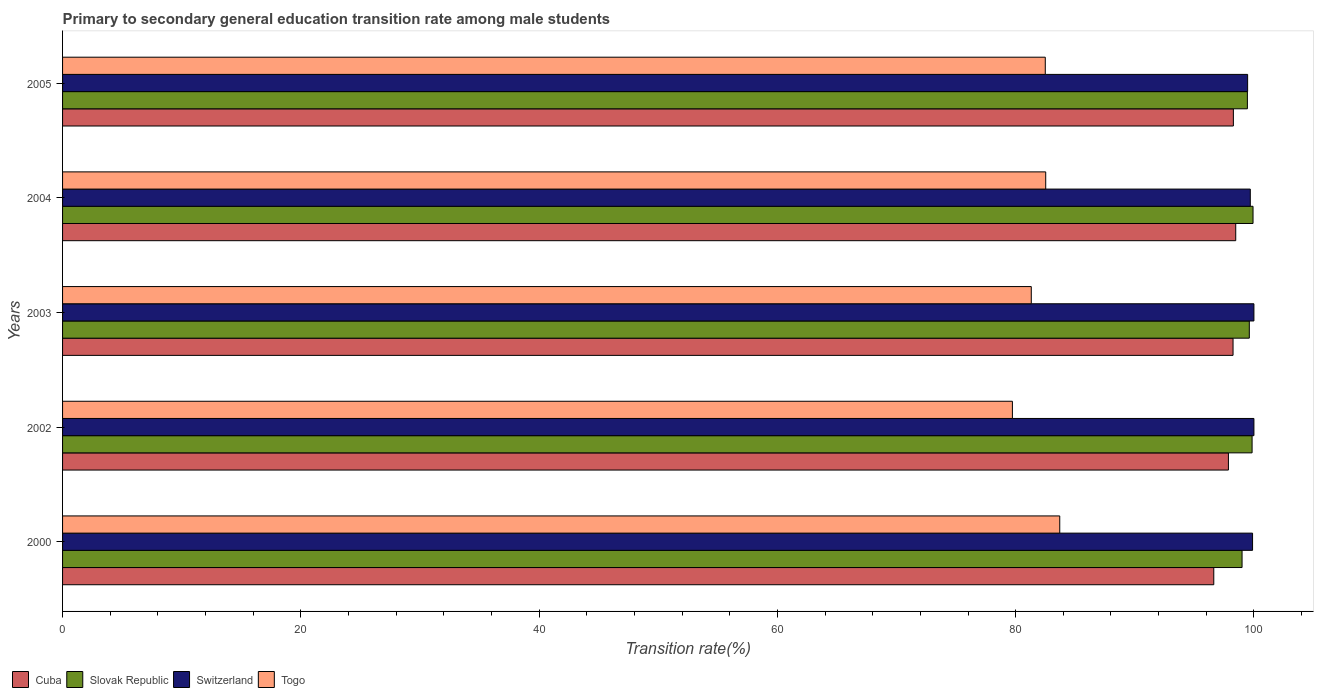How many groups of bars are there?
Keep it short and to the point. 5. Are the number of bars on each tick of the Y-axis equal?
Provide a succinct answer. Yes. How many bars are there on the 1st tick from the top?
Your response must be concise. 4. How many bars are there on the 3rd tick from the bottom?
Give a very brief answer. 4. In how many cases, is the number of bars for a given year not equal to the number of legend labels?
Keep it short and to the point. 0. What is the transition rate in Togo in 2000?
Offer a terse response. 83.7. Across all years, what is the minimum transition rate in Cuba?
Your response must be concise. 96.63. In which year was the transition rate in Slovak Republic maximum?
Offer a very short reply. 2004. What is the total transition rate in Slovak Republic in the graph?
Ensure brevity in your answer.  497.84. What is the difference between the transition rate in Togo in 2003 and that in 2005?
Give a very brief answer. -1.17. What is the difference between the transition rate in Cuba in 2004 and the transition rate in Togo in 2003?
Give a very brief answer. 17.16. What is the average transition rate in Cuba per year?
Provide a succinct answer. 97.9. In the year 2005, what is the difference between the transition rate in Cuba and transition rate in Togo?
Provide a short and direct response. 15.79. In how many years, is the transition rate in Slovak Republic greater than 12 %?
Offer a very short reply. 5. What is the ratio of the transition rate in Cuba in 2002 to that in 2003?
Provide a succinct answer. 1. Is the transition rate in Togo in 2000 less than that in 2005?
Your response must be concise. No. Is the difference between the transition rate in Cuba in 2003 and 2004 greater than the difference between the transition rate in Togo in 2003 and 2004?
Ensure brevity in your answer.  Yes. What is the difference between the highest and the second highest transition rate in Togo?
Make the answer very short. 1.18. What is the difference between the highest and the lowest transition rate in Togo?
Give a very brief answer. 3.97. Is it the case that in every year, the sum of the transition rate in Togo and transition rate in Switzerland is greater than the sum of transition rate in Cuba and transition rate in Slovak Republic?
Your response must be concise. Yes. What does the 3rd bar from the top in 2005 represents?
Provide a succinct answer. Slovak Republic. What does the 2nd bar from the bottom in 2004 represents?
Your answer should be compact. Slovak Republic. How many bars are there?
Give a very brief answer. 20. Are all the bars in the graph horizontal?
Provide a succinct answer. Yes. How many years are there in the graph?
Give a very brief answer. 5. Are the values on the major ticks of X-axis written in scientific E-notation?
Give a very brief answer. No. Does the graph contain any zero values?
Your answer should be very brief. No. Where does the legend appear in the graph?
Your response must be concise. Bottom left. How many legend labels are there?
Offer a terse response. 4. What is the title of the graph?
Offer a very short reply. Primary to secondary general education transition rate among male students. Does "Saudi Arabia" appear as one of the legend labels in the graph?
Your answer should be very brief. No. What is the label or title of the X-axis?
Your response must be concise. Transition rate(%). What is the Transition rate(%) of Cuba in 2000?
Offer a very short reply. 96.63. What is the Transition rate(%) of Slovak Republic in 2000?
Provide a succinct answer. 99. What is the Transition rate(%) of Switzerland in 2000?
Ensure brevity in your answer.  99.89. What is the Transition rate(%) of Togo in 2000?
Provide a short and direct response. 83.7. What is the Transition rate(%) in Cuba in 2002?
Offer a terse response. 97.86. What is the Transition rate(%) of Slovak Republic in 2002?
Offer a very short reply. 99.85. What is the Transition rate(%) in Switzerland in 2002?
Offer a terse response. 100. What is the Transition rate(%) of Togo in 2002?
Provide a succinct answer. 79.73. What is the Transition rate(%) of Cuba in 2003?
Ensure brevity in your answer.  98.25. What is the Transition rate(%) of Slovak Republic in 2003?
Your response must be concise. 99.61. What is the Transition rate(%) of Switzerland in 2003?
Make the answer very short. 100. What is the Transition rate(%) in Togo in 2003?
Ensure brevity in your answer.  81.31. What is the Transition rate(%) in Cuba in 2004?
Your answer should be very brief. 98.47. What is the Transition rate(%) of Slovak Republic in 2004?
Your response must be concise. 99.93. What is the Transition rate(%) in Switzerland in 2004?
Give a very brief answer. 99.7. What is the Transition rate(%) in Togo in 2004?
Ensure brevity in your answer.  82.52. What is the Transition rate(%) in Cuba in 2005?
Ensure brevity in your answer.  98.28. What is the Transition rate(%) of Slovak Republic in 2005?
Your answer should be compact. 99.45. What is the Transition rate(%) of Switzerland in 2005?
Provide a succinct answer. 99.47. What is the Transition rate(%) in Togo in 2005?
Your response must be concise. 82.49. Across all years, what is the maximum Transition rate(%) of Cuba?
Ensure brevity in your answer.  98.47. Across all years, what is the maximum Transition rate(%) of Slovak Republic?
Keep it short and to the point. 99.93. Across all years, what is the maximum Transition rate(%) in Togo?
Provide a short and direct response. 83.7. Across all years, what is the minimum Transition rate(%) in Cuba?
Ensure brevity in your answer.  96.63. Across all years, what is the minimum Transition rate(%) in Slovak Republic?
Keep it short and to the point. 99. Across all years, what is the minimum Transition rate(%) in Switzerland?
Your response must be concise. 99.47. Across all years, what is the minimum Transition rate(%) of Togo?
Your answer should be compact. 79.73. What is the total Transition rate(%) of Cuba in the graph?
Offer a terse response. 489.49. What is the total Transition rate(%) in Slovak Republic in the graph?
Keep it short and to the point. 497.84. What is the total Transition rate(%) in Switzerland in the graph?
Keep it short and to the point. 499.05. What is the total Transition rate(%) of Togo in the graph?
Give a very brief answer. 409.75. What is the difference between the Transition rate(%) of Cuba in 2000 and that in 2002?
Give a very brief answer. -1.23. What is the difference between the Transition rate(%) in Slovak Republic in 2000 and that in 2002?
Provide a succinct answer. -0.84. What is the difference between the Transition rate(%) in Switzerland in 2000 and that in 2002?
Your response must be concise. -0.11. What is the difference between the Transition rate(%) of Togo in 2000 and that in 2002?
Provide a succinct answer. 3.97. What is the difference between the Transition rate(%) of Cuba in 2000 and that in 2003?
Give a very brief answer. -1.62. What is the difference between the Transition rate(%) in Slovak Republic in 2000 and that in 2003?
Offer a very short reply. -0.61. What is the difference between the Transition rate(%) of Switzerland in 2000 and that in 2003?
Offer a very short reply. -0.11. What is the difference between the Transition rate(%) in Togo in 2000 and that in 2003?
Provide a succinct answer. 2.39. What is the difference between the Transition rate(%) of Cuba in 2000 and that in 2004?
Keep it short and to the point. -1.84. What is the difference between the Transition rate(%) of Slovak Republic in 2000 and that in 2004?
Provide a short and direct response. -0.92. What is the difference between the Transition rate(%) in Switzerland in 2000 and that in 2004?
Offer a terse response. 0.19. What is the difference between the Transition rate(%) of Togo in 2000 and that in 2004?
Provide a short and direct response. 1.18. What is the difference between the Transition rate(%) of Cuba in 2000 and that in 2005?
Your answer should be very brief. -1.64. What is the difference between the Transition rate(%) of Slovak Republic in 2000 and that in 2005?
Ensure brevity in your answer.  -0.45. What is the difference between the Transition rate(%) in Switzerland in 2000 and that in 2005?
Offer a very short reply. 0.41. What is the difference between the Transition rate(%) of Togo in 2000 and that in 2005?
Your response must be concise. 1.21. What is the difference between the Transition rate(%) of Cuba in 2002 and that in 2003?
Provide a succinct answer. -0.39. What is the difference between the Transition rate(%) in Slovak Republic in 2002 and that in 2003?
Make the answer very short. 0.23. What is the difference between the Transition rate(%) of Togo in 2002 and that in 2003?
Your answer should be compact. -1.58. What is the difference between the Transition rate(%) of Cuba in 2002 and that in 2004?
Keep it short and to the point. -0.61. What is the difference between the Transition rate(%) in Slovak Republic in 2002 and that in 2004?
Your answer should be very brief. -0.08. What is the difference between the Transition rate(%) of Switzerland in 2002 and that in 2004?
Make the answer very short. 0.3. What is the difference between the Transition rate(%) of Togo in 2002 and that in 2004?
Your answer should be very brief. -2.8. What is the difference between the Transition rate(%) in Cuba in 2002 and that in 2005?
Your answer should be compact. -0.42. What is the difference between the Transition rate(%) of Slovak Republic in 2002 and that in 2005?
Provide a succinct answer. 0.39. What is the difference between the Transition rate(%) in Switzerland in 2002 and that in 2005?
Make the answer very short. 0.53. What is the difference between the Transition rate(%) in Togo in 2002 and that in 2005?
Give a very brief answer. -2.76. What is the difference between the Transition rate(%) in Cuba in 2003 and that in 2004?
Your answer should be very brief. -0.23. What is the difference between the Transition rate(%) in Slovak Republic in 2003 and that in 2004?
Ensure brevity in your answer.  -0.31. What is the difference between the Transition rate(%) in Switzerland in 2003 and that in 2004?
Offer a terse response. 0.3. What is the difference between the Transition rate(%) of Togo in 2003 and that in 2004?
Give a very brief answer. -1.21. What is the difference between the Transition rate(%) in Cuba in 2003 and that in 2005?
Ensure brevity in your answer.  -0.03. What is the difference between the Transition rate(%) of Slovak Republic in 2003 and that in 2005?
Your answer should be compact. 0.16. What is the difference between the Transition rate(%) of Switzerland in 2003 and that in 2005?
Provide a succinct answer. 0.53. What is the difference between the Transition rate(%) in Togo in 2003 and that in 2005?
Provide a succinct answer. -1.17. What is the difference between the Transition rate(%) in Cuba in 2004 and that in 2005?
Offer a very short reply. 0.2. What is the difference between the Transition rate(%) in Slovak Republic in 2004 and that in 2005?
Provide a succinct answer. 0.47. What is the difference between the Transition rate(%) of Switzerland in 2004 and that in 2005?
Keep it short and to the point. 0.22. What is the difference between the Transition rate(%) in Togo in 2004 and that in 2005?
Provide a short and direct response. 0.04. What is the difference between the Transition rate(%) in Cuba in 2000 and the Transition rate(%) in Slovak Republic in 2002?
Make the answer very short. -3.21. What is the difference between the Transition rate(%) in Cuba in 2000 and the Transition rate(%) in Switzerland in 2002?
Offer a very short reply. -3.37. What is the difference between the Transition rate(%) of Cuba in 2000 and the Transition rate(%) of Togo in 2002?
Offer a terse response. 16.9. What is the difference between the Transition rate(%) in Slovak Republic in 2000 and the Transition rate(%) in Switzerland in 2002?
Offer a very short reply. -1. What is the difference between the Transition rate(%) in Slovak Republic in 2000 and the Transition rate(%) in Togo in 2002?
Your response must be concise. 19.28. What is the difference between the Transition rate(%) in Switzerland in 2000 and the Transition rate(%) in Togo in 2002?
Keep it short and to the point. 20.16. What is the difference between the Transition rate(%) in Cuba in 2000 and the Transition rate(%) in Slovak Republic in 2003?
Give a very brief answer. -2.98. What is the difference between the Transition rate(%) in Cuba in 2000 and the Transition rate(%) in Switzerland in 2003?
Offer a terse response. -3.37. What is the difference between the Transition rate(%) of Cuba in 2000 and the Transition rate(%) of Togo in 2003?
Your response must be concise. 15.32. What is the difference between the Transition rate(%) in Slovak Republic in 2000 and the Transition rate(%) in Switzerland in 2003?
Ensure brevity in your answer.  -1. What is the difference between the Transition rate(%) in Slovak Republic in 2000 and the Transition rate(%) in Togo in 2003?
Ensure brevity in your answer.  17.69. What is the difference between the Transition rate(%) in Switzerland in 2000 and the Transition rate(%) in Togo in 2003?
Provide a succinct answer. 18.57. What is the difference between the Transition rate(%) in Cuba in 2000 and the Transition rate(%) in Slovak Republic in 2004?
Your response must be concise. -3.29. What is the difference between the Transition rate(%) of Cuba in 2000 and the Transition rate(%) of Switzerland in 2004?
Your answer should be very brief. -3.06. What is the difference between the Transition rate(%) in Cuba in 2000 and the Transition rate(%) in Togo in 2004?
Ensure brevity in your answer.  14.11. What is the difference between the Transition rate(%) in Slovak Republic in 2000 and the Transition rate(%) in Switzerland in 2004?
Keep it short and to the point. -0.69. What is the difference between the Transition rate(%) of Slovak Republic in 2000 and the Transition rate(%) of Togo in 2004?
Give a very brief answer. 16.48. What is the difference between the Transition rate(%) of Switzerland in 2000 and the Transition rate(%) of Togo in 2004?
Offer a terse response. 17.36. What is the difference between the Transition rate(%) in Cuba in 2000 and the Transition rate(%) in Slovak Republic in 2005?
Your answer should be compact. -2.82. What is the difference between the Transition rate(%) in Cuba in 2000 and the Transition rate(%) in Switzerland in 2005?
Provide a short and direct response. -2.84. What is the difference between the Transition rate(%) in Cuba in 2000 and the Transition rate(%) in Togo in 2005?
Provide a short and direct response. 14.14. What is the difference between the Transition rate(%) in Slovak Republic in 2000 and the Transition rate(%) in Switzerland in 2005?
Ensure brevity in your answer.  -0.47. What is the difference between the Transition rate(%) in Slovak Republic in 2000 and the Transition rate(%) in Togo in 2005?
Give a very brief answer. 16.52. What is the difference between the Transition rate(%) of Switzerland in 2000 and the Transition rate(%) of Togo in 2005?
Offer a terse response. 17.4. What is the difference between the Transition rate(%) of Cuba in 2002 and the Transition rate(%) of Slovak Republic in 2003?
Provide a short and direct response. -1.75. What is the difference between the Transition rate(%) in Cuba in 2002 and the Transition rate(%) in Switzerland in 2003?
Provide a succinct answer. -2.14. What is the difference between the Transition rate(%) in Cuba in 2002 and the Transition rate(%) in Togo in 2003?
Give a very brief answer. 16.55. What is the difference between the Transition rate(%) of Slovak Republic in 2002 and the Transition rate(%) of Switzerland in 2003?
Provide a short and direct response. -0.15. What is the difference between the Transition rate(%) in Slovak Republic in 2002 and the Transition rate(%) in Togo in 2003?
Offer a terse response. 18.53. What is the difference between the Transition rate(%) in Switzerland in 2002 and the Transition rate(%) in Togo in 2003?
Make the answer very short. 18.69. What is the difference between the Transition rate(%) of Cuba in 2002 and the Transition rate(%) of Slovak Republic in 2004?
Provide a short and direct response. -2.07. What is the difference between the Transition rate(%) in Cuba in 2002 and the Transition rate(%) in Switzerland in 2004?
Your response must be concise. -1.84. What is the difference between the Transition rate(%) of Cuba in 2002 and the Transition rate(%) of Togo in 2004?
Make the answer very short. 15.34. What is the difference between the Transition rate(%) in Slovak Republic in 2002 and the Transition rate(%) in Switzerland in 2004?
Give a very brief answer. 0.15. What is the difference between the Transition rate(%) in Slovak Republic in 2002 and the Transition rate(%) in Togo in 2004?
Give a very brief answer. 17.32. What is the difference between the Transition rate(%) in Switzerland in 2002 and the Transition rate(%) in Togo in 2004?
Give a very brief answer. 17.48. What is the difference between the Transition rate(%) in Cuba in 2002 and the Transition rate(%) in Slovak Republic in 2005?
Keep it short and to the point. -1.59. What is the difference between the Transition rate(%) in Cuba in 2002 and the Transition rate(%) in Switzerland in 2005?
Your response must be concise. -1.61. What is the difference between the Transition rate(%) in Cuba in 2002 and the Transition rate(%) in Togo in 2005?
Provide a succinct answer. 15.37. What is the difference between the Transition rate(%) in Slovak Republic in 2002 and the Transition rate(%) in Switzerland in 2005?
Give a very brief answer. 0.37. What is the difference between the Transition rate(%) of Slovak Republic in 2002 and the Transition rate(%) of Togo in 2005?
Provide a succinct answer. 17.36. What is the difference between the Transition rate(%) in Switzerland in 2002 and the Transition rate(%) in Togo in 2005?
Provide a succinct answer. 17.51. What is the difference between the Transition rate(%) in Cuba in 2003 and the Transition rate(%) in Slovak Republic in 2004?
Provide a short and direct response. -1.68. What is the difference between the Transition rate(%) in Cuba in 2003 and the Transition rate(%) in Switzerland in 2004?
Provide a succinct answer. -1.45. What is the difference between the Transition rate(%) of Cuba in 2003 and the Transition rate(%) of Togo in 2004?
Offer a terse response. 15.72. What is the difference between the Transition rate(%) in Slovak Republic in 2003 and the Transition rate(%) in Switzerland in 2004?
Ensure brevity in your answer.  -0.08. What is the difference between the Transition rate(%) in Slovak Republic in 2003 and the Transition rate(%) in Togo in 2004?
Offer a terse response. 17.09. What is the difference between the Transition rate(%) of Switzerland in 2003 and the Transition rate(%) of Togo in 2004?
Offer a terse response. 17.48. What is the difference between the Transition rate(%) in Cuba in 2003 and the Transition rate(%) in Slovak Republic in 2005?
Provide a short and direct response. -1.2. What is the difference between the Transition rate(%) in Cuba in 2003 and the Transition rate(%) in Switzerland in 2005?
Offer a very short reply. -1.22. What is the difference between the Transition rate(%) of Cuba in 2003 and the Transition rate(%) of Togo in 2005?
Your response must be concise. 15.76. What is the difference between the Transition rate(%) of Slovak Republic in 2003 and the Transition rate(%) of Switzerland in 2005?
Provide a succinct answer. 0.14. What is the difference between the Transition rate(%) in Slovak Republic in 2003 and the Transition rate(%) in Togo in 2005?
Keep it short and to the point. 17.13. What is the difference between the Transition rate(%) in Switzerland in 2003 and the Transition rate(%) in Togo in 2005?
Offer a very short reply. 17.51. What is the difference between the Transition rate(%) of Cuba in 2004 and the Transition rate(%) of Slovak Republic in 2005?
Make the answer very short. -0.98. What is the difference between the Transition rate(%) of Cuba in 2004 and the Transition rate(%) of Switzerland in 2005?
Your response must be concise. -1. What is the difference between the Transition rate(%) in Cuba in 2004 and the Transition rate(%) in Togo in 2005?
Your response must be concise. 15.99. What is the difference between the Transition rate(%) in Slovak Republic in 2004 and the Transition rate(%) in Switzerland in 2005?
Ensure brevity in your answer.  0.45. What is the difference between the Transition rate(%) of Slovak Republic in 2004 and the Transition rate(%) of Togo in 2005?
Offer a very short reply. 17.44. What is the difference between the Transition rate(%) in Switzerland in 2004 and the Transition rate(%) in Togo in 2005?
Keep it short and to the point. 17.21. What is the average Transition rate(%) in Cuba per year?
Provide a succinct answer. 97.9. What is the average Transition rate(%) in Slovak Republic per year?
Give a very brief answer. 99.57. What is the average Transition rate(%) in Switzerland per year?
Your response must be concise. 99.81. What is the average Transition rate(%) in Togo per year?
Keep it short and to the point. 81.95. In the year 2000, what is the difference between the Transition rate(%) of Cuba and Transition rate(%) of Slovak Republic?
Your answer should be compact. -2.37. In the year 2000, what is the difference between the Transition rate(%) in Cuba and Transition rate(%) in Switzerland?
Your answer should be compact. -3.26. In the year 2000, what is the difference between the Transition rate(%) in Cuba and Transition rate(%) in Togo?
Offer a very short reply. 12.93. In the year 2000, what is the difference between the Transition rate(%) in Slovak Republic and Transition rate(%) in Switzerland?
Your answer should be compact. -0.88. In the year 2000, what is the difference between the Transition rate(%) of Slovak Republic and Transition rate(%) of Togo?
Give a very brief answer. 15.3. In the year 2000, what is the difference between the Transition rate(%) of Switzerland and Transition rate(%) of Togo?
Provide a short and direct response. 16.19. In the year 2002, what is the difference between the Transition rate(%) of Cuba and Transition rate(%) of Slovak Republic?
Your answer should be very brief. -1.99. In the year 2002, what is the difference between the Transition rate(%) in Cuba and Transition rate(%) in Switzerland?
Ensure brevity in your answer.  -2.14. In the year 2002, what is the difference between the Transition rate(%) in Cuba and Transition rate(%) in Togo?
Your answer should be compact. 18.13. In the year 2002, what is the difference between the Transition rate(%) of Slovak Republic and Transition rate(%) of Switzerland?
Give a very brief answer. -0.15. In the year 2002, what is the difference between the Transition rate(%) in Slovak Republic and Transition rate(%) in Togo?
Your response must be concise. 20.12. In the year 2002, what is the difference between the Transition rate(%) of Switzerland and Transition rate(%) of Togo?
Make the answer very short. 20.27. In the year 2003, what is the difference between the Transition rate(%) of Cuba and Transition rate(%) of Slovak Republic?
Provide a short and direct response. -1.37. In the year 2003, what is the difference between the Transition rate(%) in Cuba and Transition rate(%) in Switzerland?
Your response must be concise. -1.75. In the year 2003, what is the difference between the Transition rate(%) in Cuba and Transition rate(%) in Togo?
Your response must be concise. 16.93. In the year 2003, what is the difference between the Transition rate(%) of Slovak Republic and Transition rate(%) of Switzerland?
Ensure brevity in your answer.  -0.39. In the year 2003, what is the difference between the Transition rate(%) of Slovak Republic and Transition rate(%) of Togo?
Give a very brief answer. 18.3. In the year 2003, what is the difference between the Transition rate(%) of Switzerland and Transition rate(%) of Togo?
Your answer should be compact. 18.69. In the year 2004, what is the difference between the Transition rate(%) of Cuba and Transition rate(%) of Slovak Republic?
Offer a terse response. -1.45. In the year 2004, what is the difference between the Transition rate(%) in Cuba and Transition rate(%) in Switzerland?
Offer a terse response. -1.22. In the year 2004, what is the difference between the Transition rate(%) in Cuba and Transition rate(%) in Togo?
Keep it short and to the point. 15.95. In the year 2004, what is the difference between the Transition rate(%) in Slovak Republic and Transition rate(%) in Switzerland?
Make the answer very short. 0.23. In the year 2004, what is the difference between the Transition rate(%) in Slovak Republic and Transition rate(%) in Togo?
Your answer should be compact. 17.4. In the year 2004, what is the difference between the Transition rate(%) of Switzerland and Transition rate(%) of Togo?
Your response must be concise. 17.17. In the year 2005, what is the difference between the Transition rate(%) in Cuba and Transition rate(%) in Slovak Republic?
Give a very brief answer. -1.18. In the year 2005, what is the difference between the Transition rate(%) in Cuba and Transition rate(%) in Switzerland?
Offer a terse response. -1.2. In the year 2005, what is the difference between the Transition rate(%) of Cuba and Transition rate(%) of Togo?
Your answer should be compact. 15.79. In the year 2005, what is the difference between the Transition rate(%) of Slovak Republic and Transition rate(%) of Switzerland?
Offer a terse response. -0.02. In the year 2005, what is the difference between the Transition rate(%) of Slovak Republic and Transition rate(%) of Togo?
Your answer should be compact. 16.96. In the year 2005, what is the difference between the Transition rate(%) of Switzerland and Transition rate(%) of Togo?
Make the answer very short. 16.98. What is the ratio of the Transition rate(%) in Cuba in 2000 to that in 2002?
Provide a short and direct response. 0.99. What is the ratio of the Transition rate(%) in Switzerland in 2000 to that in 2002?
Offer a terse response. 1. What is the ratio of the Transition rate(%) of Togo in 2000 to that in 2002?
Ensure brevity in your answer.  1.05. What is the ratio of the Transition rate(%) in Cuba in 2000 to that in 2003?
Give a very brief answer. 0.98. What is the ratio of the Transition rate(%) in Slovak Republic in 2000 to that in 2003?
Give a very brief answer. 0.99. What is the ratio of the Transition rate(%) of Switzerland in 2000 to that in 2003?
Provide a succinct answer. 1. What is the ratio of the Transition rate(%) in Togo in 2000 to that in 2003?
Provide a short and direct response. 1.03. What is the ratio of the Transition rate(%) in Cuba in 2000 to that in 2004?
Provide a succinct answer. 0.98. What is the ratio of the Transition rate(%) of Switzerland in 2000 to that in 2004?
Your answer should be compact. 1. What is the ratio of the Transition rate(%) of Togo in 2000 to that in 2004?
Offer a very short reply. 1.01. What is the ratio of the Transition rate(%) of Cuba in 2000 to that in 2005?
Make the answer very short. 0.98. What is the ratio of the Transition rate(%) in Togo in 2000 to that in 2005?
Offer a terse response. 1.01. What is the ratio of the Transition rate(%) of Togo in 2002 to that in 2003?
Your response must be concise. 0.98. What is the ratio of the Transition rate(%) of Cuba in 2002 to that in 2004?
Ensure brevity in your answer.  0.99. What is the ratio of the Transition rate(%) of Togo in 2002 to that in 2004?
Offer a very short reply. 0.97. What is the ratio of the Transition rate(%) of Cuba in 2002 to that in 2005?
Offer a terse response. 1. What is the ratio of the Transition rate(%) of Togo in 2002 to that in 2005?
Your response must be concise. 0.97. What is the ratio of the Transition rate(%) in Cuba in 2003 to that in 2004?
Your response must be concise. 1. What is the ratio of the Transition rate(%) of Slovak Republic in 2003 to that in 2004?
Your response must be concise. 1. What is the ratio of the Transition rate(%) in Togo in 2003 to that in 2004?
Give a very brief answer. 0.99. What is the ratio of the Transition rate(%) in Switzerland in 2003 to that in 2005?
Your answer should be compact. 1.01. What is the ratio of the Transition rate(%) of Togo in 2003 to that in 2005?
Offer a very short reply. 0.99. What is the ratio of the Transition rate(%) in Cuba in 2004 to that in 2005?
Give a very brief answer. 1. What is the ratio of the Transition rate(%) in Switzerland in 2004 to that in 2005?
Give a very brief answer. 1. What is the difference between the highest and the second highest Transition rate(%) in Cuba?
Offer a terse response. 0.2. What is the difference between the highest and the second highest Transition rate(%) of Slovak Republic?
Your answer should be very brief. 0.08. What is the difference between the highest and the second highest Transition rate(%) in Togo?
Provide a succinct answer. 1.18. What is the difference between the highest and the lowest Transition rate(%) in Cuba?
Ensure brevity in your answer.  1.84. What is the difference between the highest and the lowest Transition rate(%) in Slovak Republic?
Your response must be concise. 0.92. What is the difference between the highest and the lowest Transition rate(%) of Switzerland?
Give a very brief answer. 0.53. What is the difference between the highest and the lowest Transition rate(%) of Togo?
Keep it short and to the point. 3.97. 